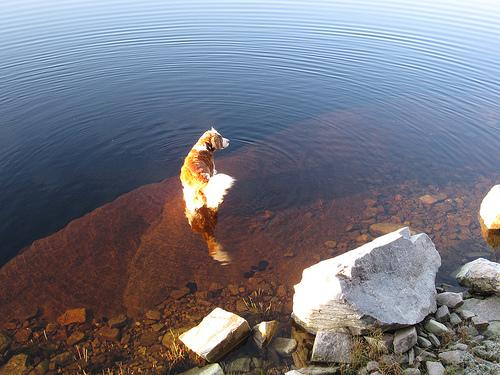Question: what scene is this?
Choices:
A. Ocean.
B. Lake.
C. Pond.
D. River.
Answer with the letter. Answer: B 